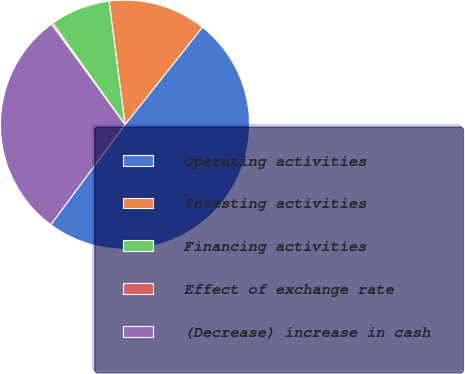<chart> <loc_0><loc_0><loc_500><loc_500><pie_chart><fcel>Operating activities<fcel>Investing activities<fcel>Financing activities<fcel>Effect of exchange rate<fcel>(Decrease) increase in cash<nl><fcel>49.47%<fcel>12.73%<fcel>7.8%<fcel>0.22%<fcel>29.78%<nl></chart> 